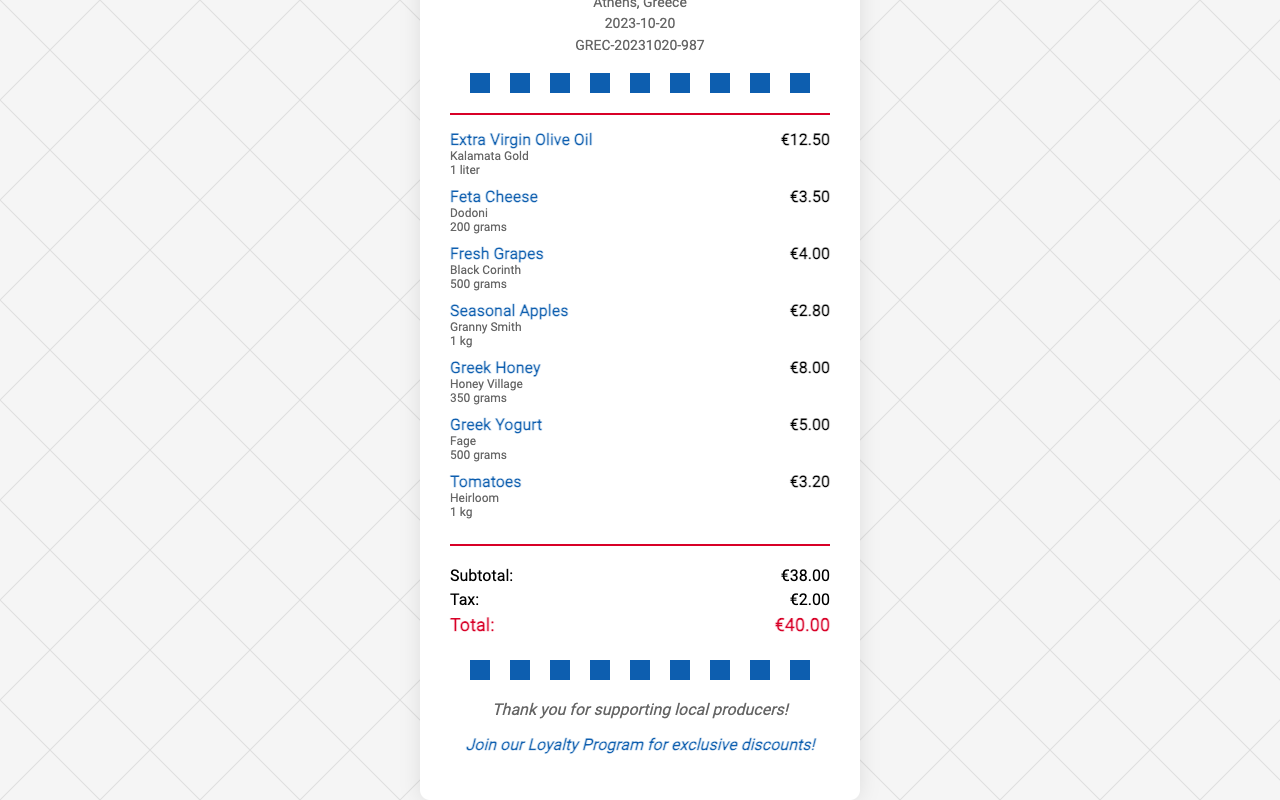What is the store name? The store name is prominently displayed at the top of the receipt, identifying the place of purchase.
Answer: Agora Market What is the location? The location is mentioned just below the store name, indicating where the market is situated.
Answer: Athens, Greece What is the total amount? The total amount is shown at the bottom of the receipt and represents the overall cost of the items purchased.
Answer: €40.00 How many grams of Feta Cheese were purchased? The quantity of Feta Cheese is specified in the item description, indicating the amount bought.
Answer: 200 grams What is the price of Extra Virgin Olive Oil? The price is displayed next to the item name and indicates the cost for the specified quantity.
Answer: €12.50 What item has the highest price? By comparing the prices listed, the item that costs the most can be identified.
Answer: Extra Virgin Olive Oil How much tax was charged? The tax is explicitly mentioned in the totals section, providing clarity on additional costs.
Answer: €2.00 What is the brand of Greek Yogurt? The brand is clearly indicated next to the item name, providing information about the manufacturer.
Answer: Fage What loyalty program is mentioned? The loyalty program is stated in the footer, suggesting a benefit for recurring customers.
Answer: Join our Loyalty Program for exclusive discounts! 